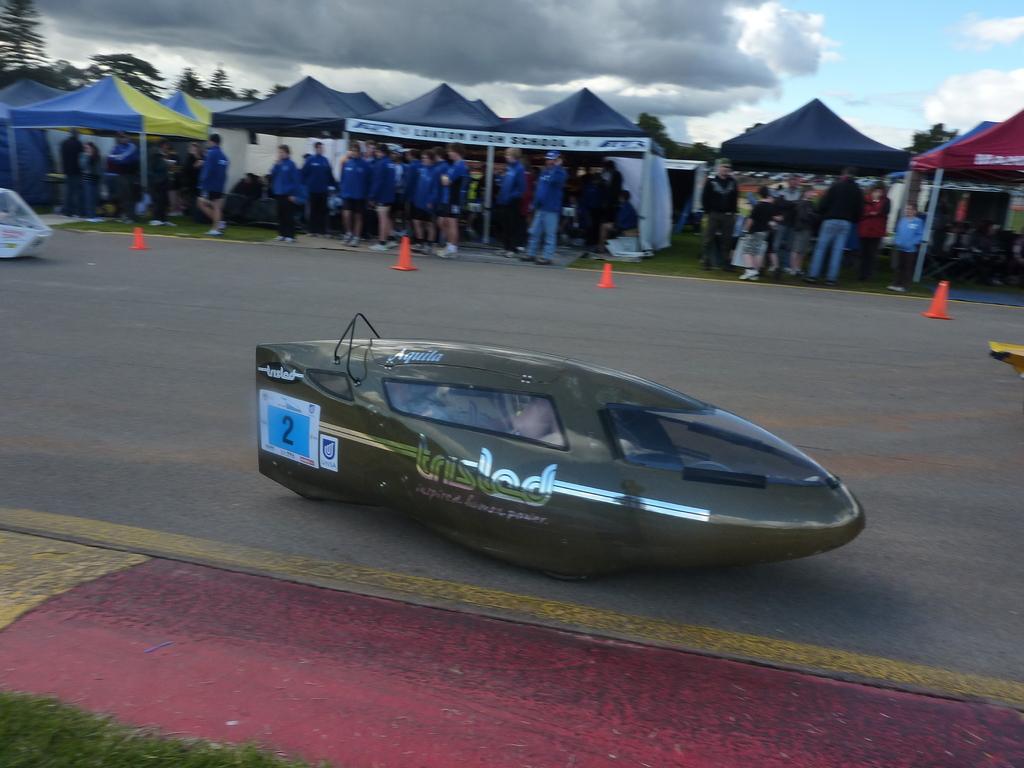Can you describe this image briefly? In this image we can see a vehicle on the road. On the vehicle something is written. In the back there are few people. And there are tents. Also there are traffic cones on the road. In the background there are trees. Also there is sky with clouds. 